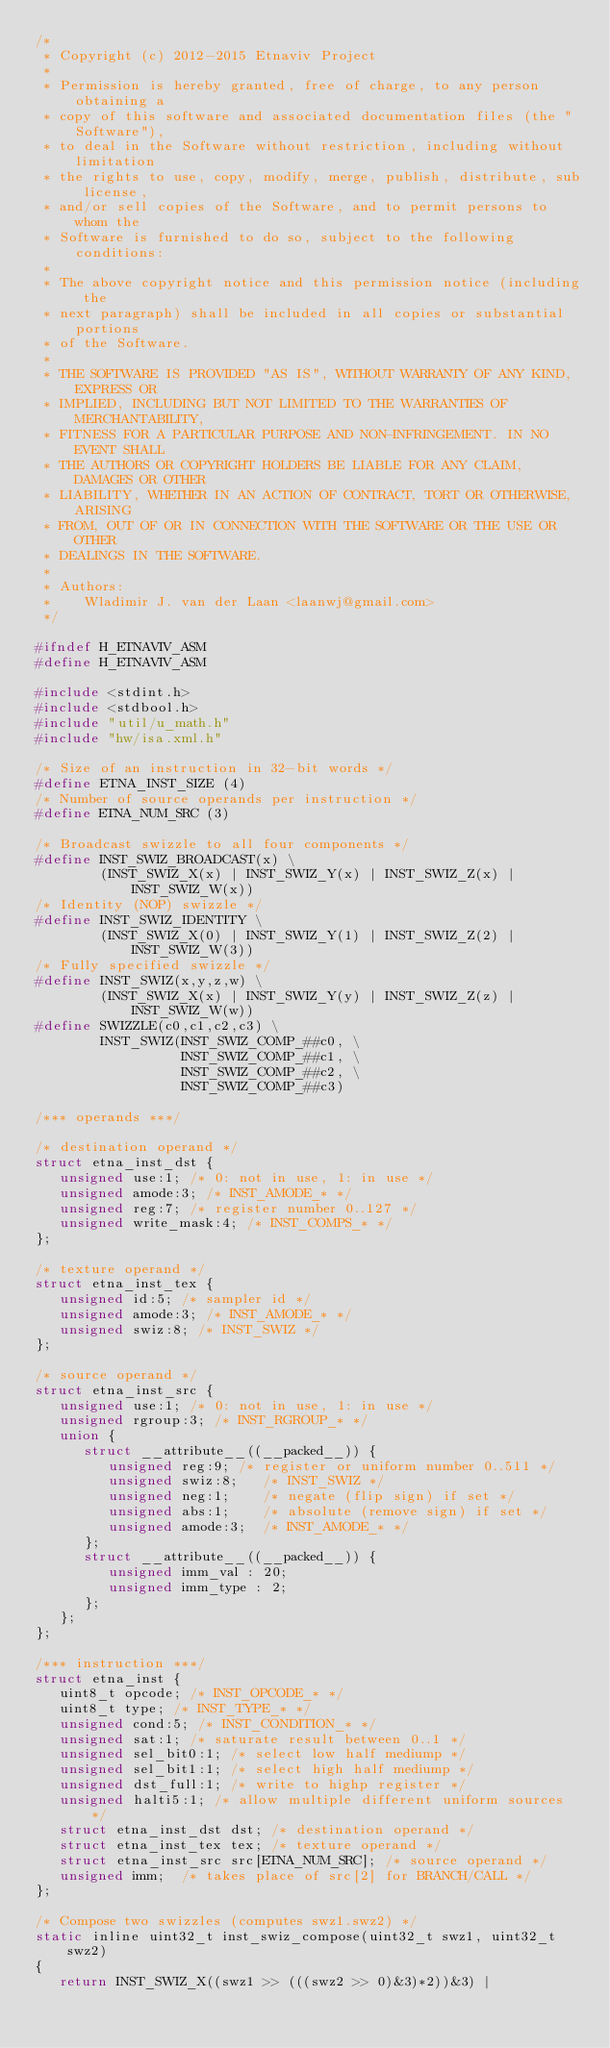Convert code to text. <code><loc_0><loc_0><loc_500><loc_500><_C_>/*
 * Copyright (c) 2012-2015 Etnaviv Project
 *
 * Permission is hereby granted, free of charge, to any person obtaining a
 * copy of this software and associated documentation files (the "Software"),
 * to deal in the Software without restriction, including without limitation
 * the rights to use, copy, modify, merge, publish, distribute, sub license,
 * and/or sell copies of the Software, and to permit persons to whom the
 * Software is furnished to do so, subject to the following conditions:
 *
 * The above copyright notice and this permission notice (including the
 * next paragraph) shall be included in all copies or substantial portions
 * of the Software.
 *
 * THE SOFTWARE IS PROVIDED "AS IS", WITHOUT WARRANTY OF ANY KIND, EXPRESS OR
 * IMPLIED, INCLUDING BUT NOT LIMITED TO THE WARRANTIES OF MERCHANTABILITY,
 * FITNESS FOR A PARTICULAR PURPOSE AND NON-INFRINGEMENT. IN NO EVENT SHALL
 * THE AUTHORS OR COPYRIGHT HOLDERS BE LIABLE FOR ANY CLAIM, DAMAGES OR OTHER
 * LIABILITY, WHETHER IN AN ACTION OF CONTRACT, TORT OR OTHERWISE, ARISING
 * FROM, OUT OF OR IN CONNECTION WITH THE SOFTWARE OR THE USE OR OTHER
 * DEALINGS IN THE SOFTWARE.
 *
 * Authors:
 *    Wladimir J. van der Laan <laanwj@gmail.com>
 */

#ifndef H_ETNAVIV_ASM
#define H_ETNAVIV_ASM

#include <stdint.h>
#include <stdbool.h>
#include "util/u_math.h"
#include "hw/isa.xml.h"

/* Size of an instruction in 32-bit words */
#define ETNA_INST_SIZE (4)
/* Number of source operands per instruction */
#define ETNA_NUM_SRC (3)

/* Broadcast swizzle to all four components */
#define INST_SWIZ_BROADCAST(x) \
        (INST_SWIZ_X(x) | INST_SWIZ_Y(x) | INST_SWIZ_Z(x) | INST_SWIZ_W(x))
/* Identity (NOP) swizzle */
#define INST_SWIZ_IDENTITY \
        (INST_SWIZ_X(0) | INST_SWIZ_Y(1) | INST_SWIZ_Z(2) | INST_SWIZ_W(3))
/* Fully specified swizzle */
#define INST_SWIZ(x,y,z,w) \
        (INST_SWIZ_X(x) | INST_SWIZ_Y(y) | INST_SWIZ_Z(z) | INST_SWIZ_W(w))
#define SWIZZLE(c0,c1,c2,c3) \
        INST_SWIZ(INST_SWIZ_COMP_##c0, \
                  INST_SWIZ_COMP_##c1, \
                  INST_SWIZ_COMP_##c2, \
                  INST_SWIZ_COMP_##c3)

/*** operands ***/

/* destination operand */
struct etna_inst_dst {
   unsigned use:1; /* 0: not in use, 1: in use */
   unsigned amode:3; /* INST_AMODE_* */
   unsigned reg:7; /* register number 0..127 */
   unsigned write_mask:4; /* INST_COMPS_* */
};

/* texture operand */
struct etna_inst_tex {
   unsigned id:5; /* sampler id */
   unsigned amode:3; /* INST_AMODE_* */
   unsigned swiz:8; /* INST_SWIZ */
};

/* source operand */
struct etna_inst_src {
   unsigned use:1; /* 0: not in use, 1: in use */
   unsigned rgroup:3; /* INST_RGROUP_* */
   union {
      struct __attribute__((__packed__)) {
         unsigned reg:9; /* register or uniform number 0..511 */
         unsigned swiz:8;   /* INST_SWIZ */
         unsigned neg:1;    /* negate (flip sign) if set */
         unsigned abs:1;    /* absolute (remove sign) if set */
         unsigned amode:3;  /* INST_AMODE_* */
      };
      struct __attribute__((__packed__)) {
         unsigned imm_val : 20;
         unsigned imm_type : 2;
      };
   };
};

/*** instruction ***/
struct etna_inst {
   uint8_t opcode; /* INST_OPCODE_* */
   uint8_t type; /* INST_TYPE_* */
   unsigned cond:5; /* INST_CONDITION_* */
   unsigned sat:1; /* saturate result between 0..1 */
   unsigned sel_bit0:1; /* select low half mediump */
   unsigned sel_bit1:1; /* select high half mediump */
   unsigned dst_full:1; /* write to highp register */
   unsigned halti5:1; /* allow multiple different uniform sources */
   struct etna_inst_dst dst; /* destination operand */
   struct etna_inst_tex tex; /* texture operand */
   struct etna_inst_src src[ETNA_NUM_SRC]; /* source operand */
   unsigned imm;  /* takes place of src[2] for BRANCH/CALL */
};

/* Compose two swizzles (computes swz1.swz2) */
static inline uint32_t inst_swiz_compose(uint32_t swz1, uint32_t swz2)
{
   return INST_SWIZ_X((swz1 >> (((swz2 >> 0)&3)*2))&3) |</code> 